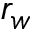Convert formula to latex. <formula><loc_0><loc_0><loc_500><loc_500>r _ { w }</formula> 